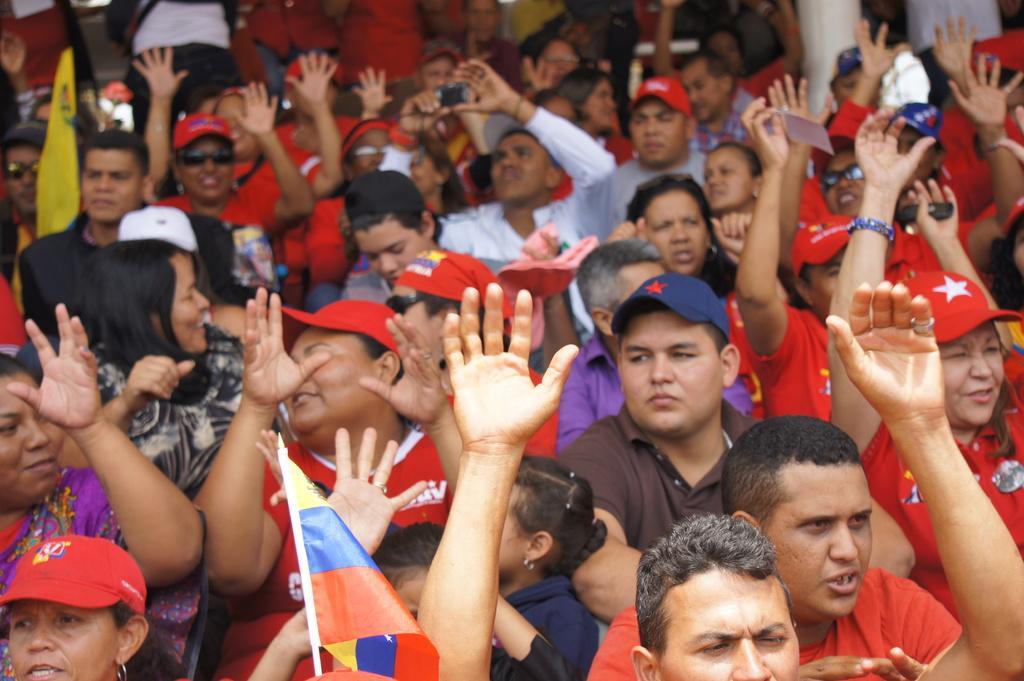How would you summarize this image in a sentence or two? In this image I can see a crowd are holding some flags in their hand. This image is taken may be during a day. 